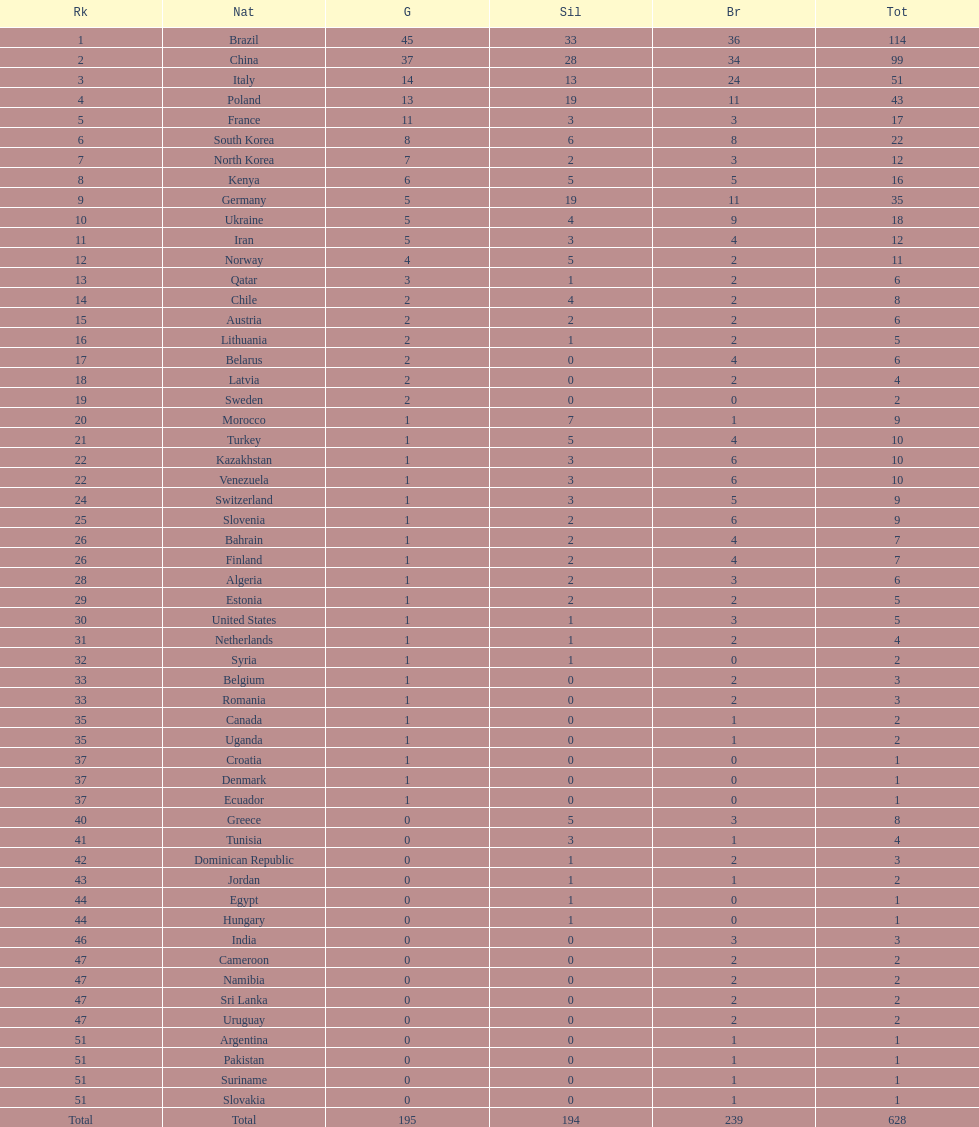Can you give me this table as a dict? {'header': ['Rk', 'Nat', 'G', 'Sil', 'Br', 'Tot'], 'rows': [['1', 'Brazil', '45', '33', '36', '114'], ['2', 'China', '37', '28', '34', '99'], ['3', 'Italy', '14', '13', '24', '51'], ['4', 'Poland', '13', '19', '11', '43'], ['5', 'France', '11', '3', '3', '17'], ['6', 'South Korea', '8', '6', '8', '22'], ['7', 'North Korea', '7', '2', '3', '12'], ['8', 'Kenya', '6', '5', '5', '16'], ['9', 'Germany', '5', '19', '11', '35'], ['10', 'Ukraine', '5', '4', '9', '18'], ['11', 'Iran', '5', '3', '4', '12'], ['12', 'Norway', '4', '5', '2', '11'], ['13', 'Qatar', '3', '1', '2', '6'], ['14', 'Chile', '2', '4', '2', '8'], ['15', 'Austria', '2', '2', '2', '6'], ['16', 'Lithuania', '2', '1', '2', '5'], ['17', 'Belarus', '2', '0', '4', '6'], ['18', 'Latvia', '2', '0', '2', '4'], ['19', 'Sweden', '2', '0', '0', '2'], ['20', 'Morocco', '1', '7', '1', '9'], ['21', 'Turkey', '1', '5', '4', '10'], ['22', 'Kazakhstan', '1', '3', '6', '10'], ['22', 'Venezuela', '1', '3', '6', '10'], ['24', 'Switzerland', '1', '3', '5', '9'], ['25', 'Slovenia', '1', '2', '6', '9'], ['26', 'Bahrain', '1', '2', '4', '7'], ['26', 'Finland', '1', '2', '4', '7'], ['28', 'Algeria', '1', '2', '3', '6'], ['29', 'Estonia', '1', '2', '2', '5'], ['30', 'United States', '1', '1', '3', '5'], ['31', 'Netherlands', '1', '1', '2', '4'], ['32', 'Syria', '1', '1', '0', '2'], ['33', 'Belgium', '1', '0', '2', '3'], ['33', 'Romania', '1', '0', '2', '3'], ['35', 'Canada', '1', '0', '1', '2'], ['35', 'Uganda', '1', '0', '1', '2'], ['37', 'Croatia', '1', '0', '0', '1'], ['37', 'Denmark', '1', '0', '0', '1'], ['37', 'Ecuador', '1', '0', '0', '1'], ['40', 'Greece', '0', '5', '3', '8'], ['41', 'Tunisia', '0', '3', '1', '4'], ['42', 'Dominican Republic', '0', '1', '2', '3'], ['43', 'Jordan', '0', '1', '1', '2'], ['44', 'Egypt', '0', '1', '0', '1'], ['44', 'Hungary', '0', '1', '0', '1'], ['46', 'India', '0', '0', '3', '3'], ['47', 'Cameroon', '0', '0', '2', '2'], ['47', 'Namibia', '0', '0', '2', '2'], ['47', 'Sri Lanka', '0', '0', '2', '2'], ['47', 'Uruguay', '0', '0', '2', '2'], ['51', 'Argentina', '0', '0', '1', '1'], ['51', 'Pakistan', '0', '0', '1', '1'], ['51', 'Suriname', '0', '0', '1', '1'], ['51', 'Slovakia', '0', '0', '1', '1'], ['Total', 'Total', '195', '194', '239', '628']]} Which nation earned the most gold medals? Brazil. 